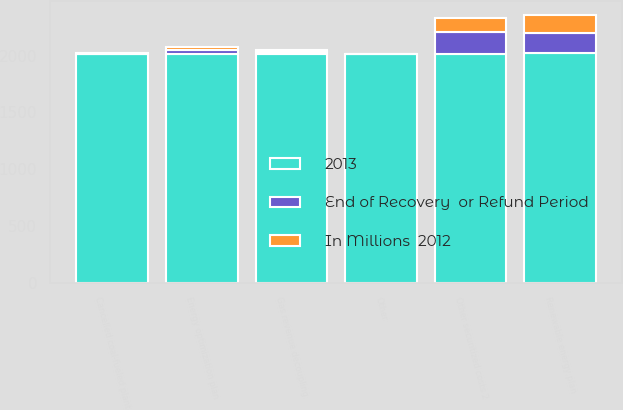<chart> <loc_0><loc_0><loc_500><loc_500><stacked_bar_chart><ecel><fcel>Energy optimization plan<fcel>Gas revenue decoupling<fcel>Cancelled coal-fueled plant<fcel>Other securitized costs 2<fcel>Other<fcel>Renewable energy plan<nl><fcel>2013<fcel>2015<fcel>2014<fcel>2014<fcel>2016<fcel>2014<fcel>2028<nl><fcel>In Millions  2012<fcel>31<fcel>17<fcel>5<fcel>129<fcel>1<fcel>159<nl><fcel>End of Recovery  or Refund Period<fcel>34<fcel>16<fcel>4<fcel>192<fcel>2<fcel>175<nl></chart> 